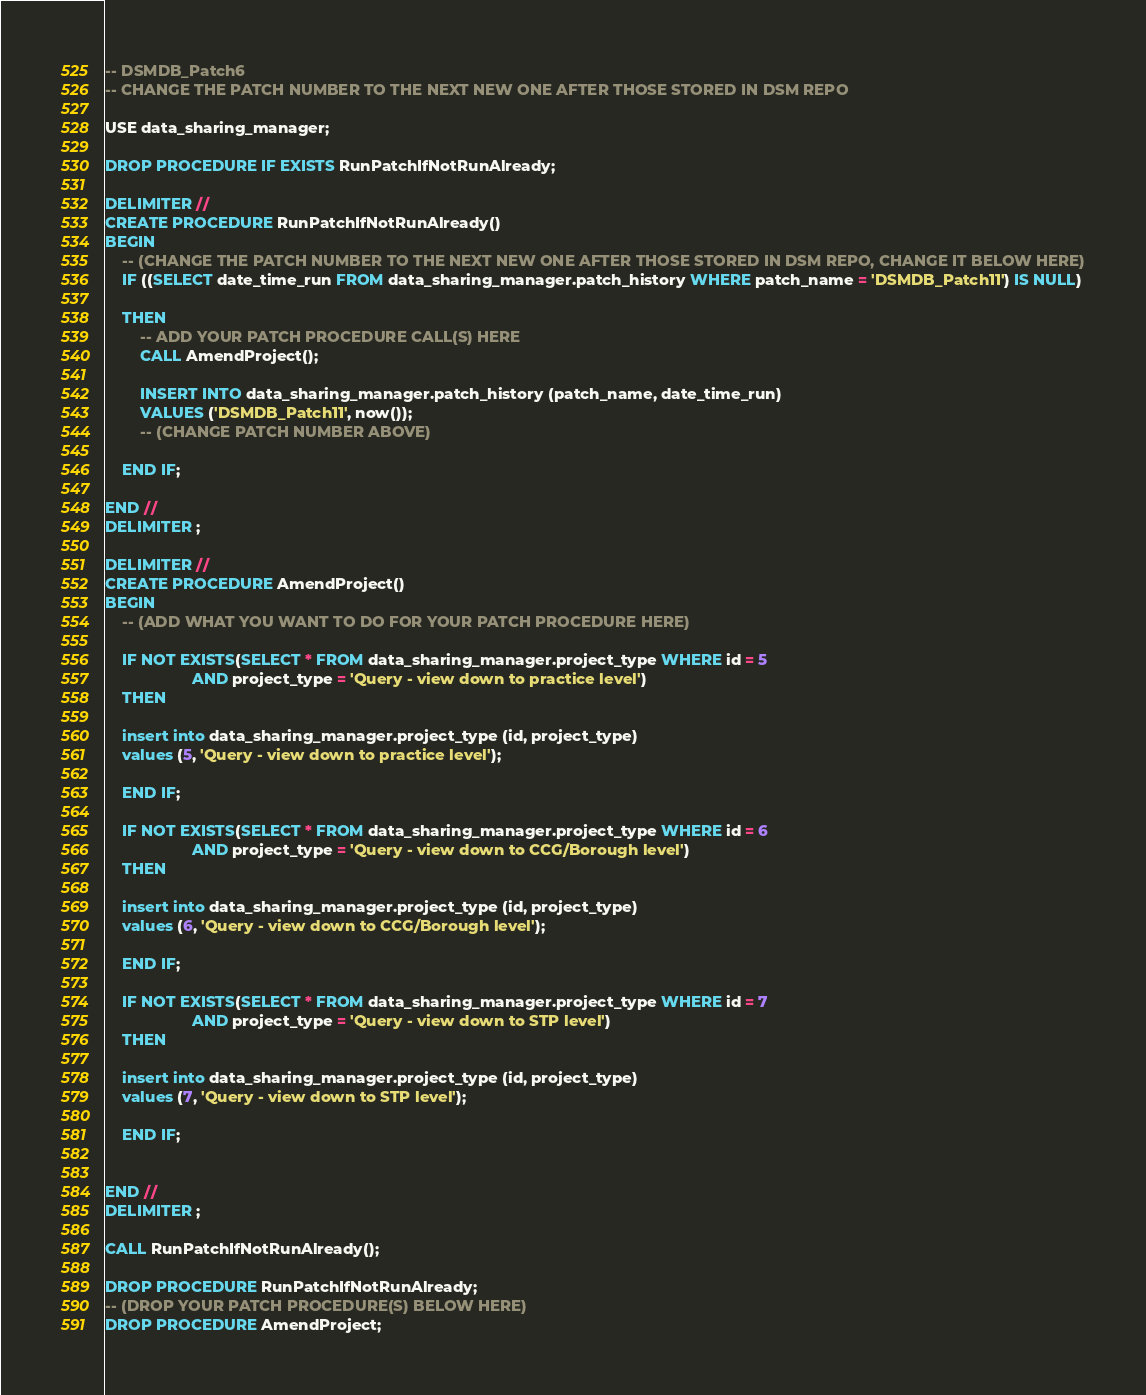<code> <loc_0><loc_0><loc_500><loc_500><_SQL_>-- DSMDB_Patch6
-- CHANGE THE PATCH NUMBER TO THE NEXT NEW ONE AFTER THOSE STORED IN DSM REPO

USE data_sharing_manager;

DROP PROCEDURE IF EXISTS RunPatchIfNotRunAlready;

DELIMITER //
CREATE PROCEDURE RunPatchIfNotRunAlready()
BEGIN
    -- (CHANGE THE PATCH NUMBER TO THE NEXT NEW ONE AFTER THOSE STORED IN DSM REPO, CHANGE IT BELOW HERE)
    IF ((SELECT date_time_run FROM data_sharing_manager.patch_history WHERE patch_name = 'DSMDB_Patch11') IS NULL)

    THEN
        -- ADD YOUR PATCH PROCEDURE CALL(S) HERE
        CALL AmendProject();

        INSERT INTO data_sharing_manager.patch_history (patch_name, date_time_run)
        VALUES ('DSMDB_Patch11', now());
        -- (CHANGE PATCH NUMBER ABOVE)

    END IF;

END //
DELIMITER ;

DELIMITER //
CREATE PROCEDURE AmendProject()
BEGIN
    -- (ADD WHAT YOU WANT TO DO FOR YOUR PATCH PROCEDURE HERE)

    IF NOT EXISTS(SELECT * FROM data_sharing_manager.project_type WHERE id = 5
					AND project_type = 'Query - view down to practice level')
	THEN

    insert into data_sharing_manager.project_type (id, project_type)
    values (5, 'Query - view down to practice level');
    
    END IF;
    
    IF NOT EXISTS(SELECT * FROM data_sharing_manager.project_type WHERE id = 6
					AND project_type = 'Query - view down to CCG/Borough level')
	THEN

    insert into data_sharing_manager.project_type (id, project_type)
    values (6, 'Query - view down to CCG/Borough level');
    
    END IF;
    
	IF NOT EXISTS(SELECT * FROM data_sharing_manager.project_type WHERE id = 7
					AND project_type = 'Query - view down to STP level')
	THEN

    insert into data_sharing_manager.project_type (id, project_type)
    values (7, 'Query - view down to STP level');
    
    END IF;


END //
DELIMITER ;

CALL RunPatchIfNotRunAlready();

DROP PROCEDURE RunPatchIfNotRunAlready;
-- (DROP YOUR PATCH PROCEDURE(S) BELOW HERE)
DROP PROCEDURE AmendProject;</code> 